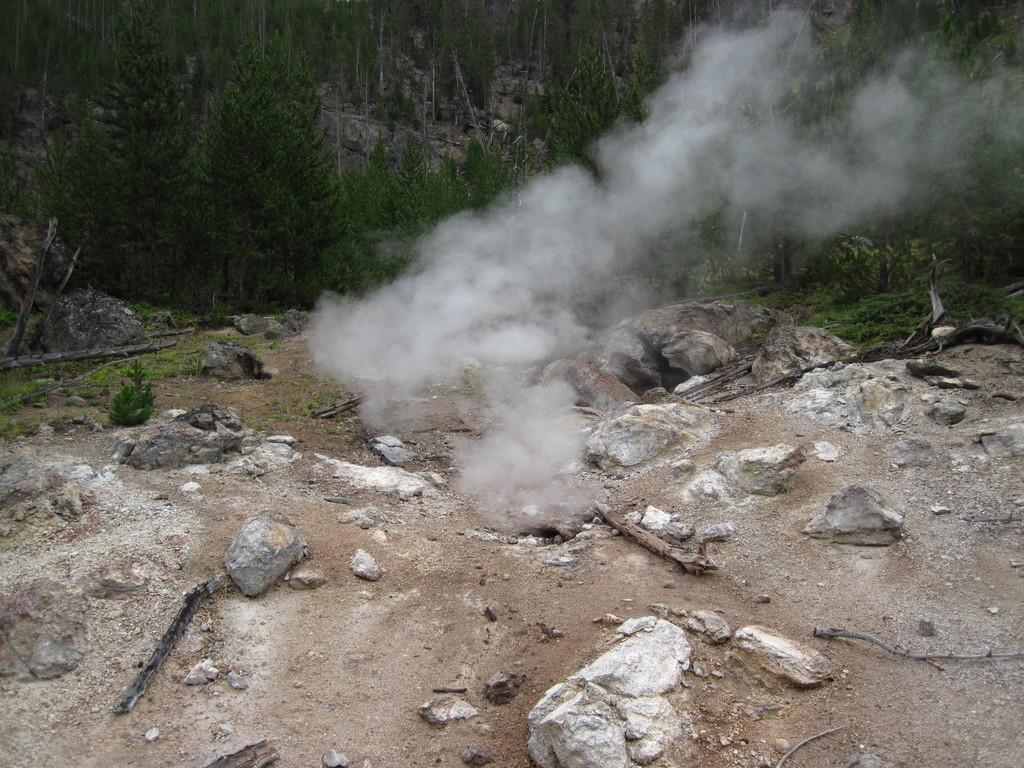What type of natural elements can be seen in the image? There are rocks in the image. What else is visible in the image besides the rocks? There appears to be smoke in the image. What can be seen in the background of the image? There are trees in the background of the image. How many cats are sitting on the cake in the image? There is no cake or cats present in the image. What type of discovery is being made in the image? There is no discovery being made in the image; it features rocks and smoke. 